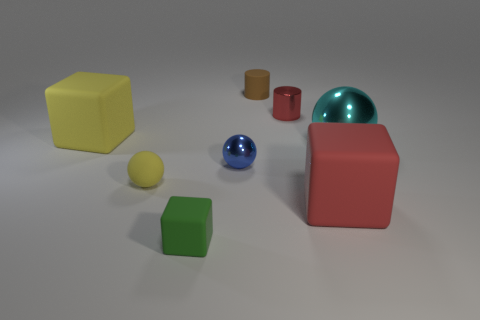There is a yellow thing in front of the big cyan shiny object; does it have the same size as the cube that is in front of the large red rubber thing?
Your answer should be compact. Yes. How many other things are there of the same size as the blue ball?
Offer a terse response. 4. What is the big object left of the shiny thing that is on the left side of the tiny metal thing that is behind the tiny blue metallic thing made of?
Make the answer very short. Rubber. There is a yellow cube; is it the same size as the matte cube to the right of the blue shiny sphere?
Give a very brief answer. Yes. What is the size of the matte cube that is both left of the shiny cylinder and behind the green thing?
Your answer should be very brief. Large. Are there any cylinders that have the same color as the small shiny ball?
Offer a very short reply. No. There is a metallic sphere that is right of the blue ball behind the red rubber object; what color is it?
Offer a very short reply. Cyan. Is the number of large cubes that are in front of the green rubber object less than the number of matte cylinders that are to the left of the tiny red shiny thing?
Your answer should be very brief. Yes. Do the green rubber thing and the cyan metal ball have the same size?
Provide a short and direct response. No. There is a tiny thing that is behind the big cyan object and in front of the small brown cylinder; what shape is it?
Offer a very short reply. Cylinder. 